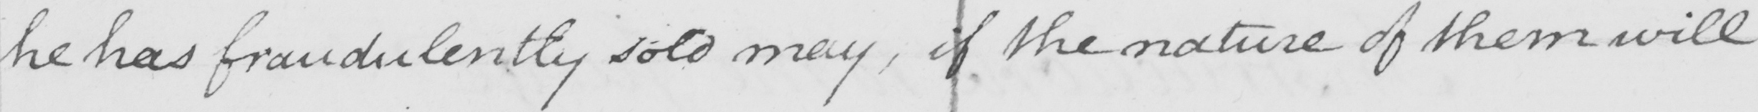What text is written in this handwritten line? he has fraudulently sold may , if the nature of them will 